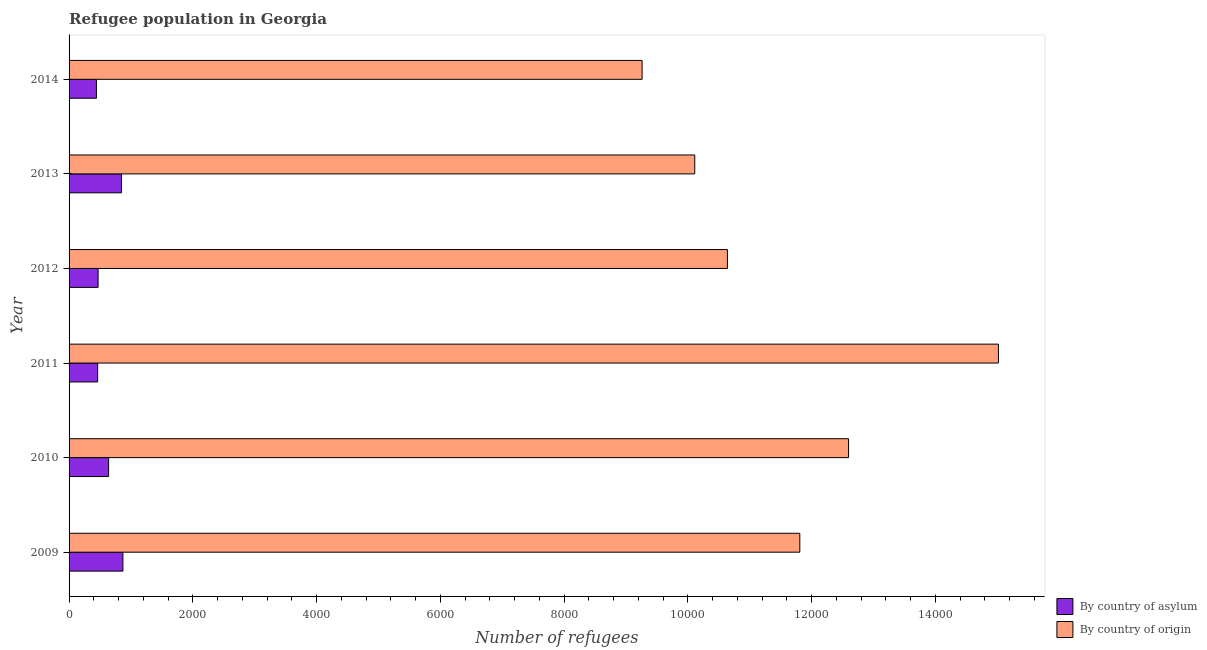How many different coloured bars are there?
Your answer should be very brief. 2. Are the number of bars per tick equal to the number of legend labels?
Keep it short and to the point. Yes. How many bars are there on the 4th tick from the bottom?
Your answer should be compact. 2. What is the label of the 4th group of bars from the top?
Your answer should be very brief. 2011. In how many cases, is the number of bars for a given year not equal to the number of legend labels?
Provide a short and direct response. 0. What is the number of refugees by country of asylum in 2014?
Make the answer very short. 442. Across all years, what is the maximum number of refugees by country of asylum?
Offer a terse response. 870. Across all years, what is the minimum number of refugees by country of origin?
Your response must be concise. 9261. What is the total number of refugees by country of asylum in the graph?
Make the answer very short. 3729. What is the difference between the number of refugees by country of asylum in 2009 and that in 2013?
Give a very brief answer. 23. What is the difference between the number of refugees by country of asylum in 2011 and the number of refugees by country of origin in 2010?
Offer a very short reply. -1.21e+04. What is the average number of refugees by country of origin per year?
Keep it short and to the point. 1.16e+04. In the year 2009, what is the difference between the number of refugees by country of origin and number of refugees by country of asylum?
Your answer should be compact. 1.09e+04. What is the ratio of the number of refugees by country of asylum in 2010 to that in 2013?
Keep it short and to the point. 0.75. Is the number of refugees by country of asylum in 2009 less than that in 2010?
Offer a terse response. No. Is the difference between the number of refugees by country of asylum in 2012 and 2013 greater than the difference between the number of refugees by country of origin in 2012 and 2013?
Ensure brevity in your answer.  No. What is the difference between the highest and the lowest number of refugees by country of origin?
Your response must be concise. 5759. Is the sum of the number of refugees by country of asylum in 2012 and 2013 greater than the maximum number of refugees by country of origin across all years?
Your answer should be compact. No. What does the 2nd bar from the top in 2009 represents?
Keep it short and to the point. By country of asylum. What does the 1st bar from the bottom in 2014 represents?
Make the answer very short. By country of asylum. Are all the bars in the graph horizontal?
Your response must be concise. Yes. Are the values on the major ticks of X-axis written in scientific E-notation?
Provide a succinct answer. No. Does the graph contain any zero values?
Your response must be concise. No. Where does the legend appear in the graph?
Your response must be concise. Bottom right. What is the title of the graph?
Your answer should be compact. Refugee population in Georgia. What is the label or title of the X-axis?
Offer a very short reply. Number of refugees. What is the Number of refugees in By country of asylum in 2009?
Give a very brief answer. 870. What is the Number of refugees in By country of origin in 2009?
Give a very brief answer. 1.18e+04. What is the Number of refugees in By country of asylum in 2010?
Your answer should be very brief. 639. What is the Number of refugees in By country of origin in 2010?
Your answer should be compact. 1.26e+04. What is the Number of refugees of By country of asylum in 2011?
Your answer should be very brief. 462. What is the Number of refugees of By country of origin in 2011?
Keep it short and to the point. 1.50e+04. What is the Number of refugees of By country of asylum in 2012?
Give a very brief answer. 469. What is the Number of refugees of By country of origin in 2012?
Your response must be concise. 1.06e+04. What is the Number of refugees in By country of asylum in 2013?
Make the answer very short. 847. What is the Number of refugees of By country of origin in 2013?
Your answer should be very brief. 1.01e+04. What is the Number of refugees of By country of asylum in 2014?
Offer a terse response. 442. What is the Number of refugees in By country of origin in 2014?
Your answer should be compact. 9261. Across all years, what is the maximum Number of refugees in By country of asylum?
Your answer should be very brief. 870. Across all years, what is the maximum Number of refugees of By country of origin?
Ensure brevity in your answer.  1.50e+04. Across all years, what is the minimum Number of refugees of By country of asylum?
Keep it short and to the point. 442. Across all years, what is the minimum Number of refugees of By country of origin?
Your answer should be compact. 9261. What is the total Number of refugees of By country of asylum in the graph?
Ensure brevity in your answer.  3729. What is the total Number of refugees in By country of origin in the graph?
Keep it short and to the point. 6.94e+04. What is the difference between the Number of refugees in By country of asylum in 2009 and that in 2010?
Offer a terse response. 231. What is the difference between the Number of refugees in By country of origin in 2009 and that in 2010?
Offer a terse response. -788. What is the difference between the Number of refugees of By country of asylum in 2009 and that in 2011?
Offer a very short reply. 408. What is the difference between the Number of refugees of By country of origin in 2009 and that in 2011?
Provide a succinct answer. -3210. What is the difference between the Number of refugees of By country of asylum in 2009 and that in 2012?
Your answer should be very brief. 401. What is the difference between the Number of refugees in By country of origin in 2009 and that in 2012?
Keep it short and to the point. 1170. What is the difference between the Number of refugees in By country of asylum in 2009 and that in 2013?
Provide a short and direct response. 23. What is the difference between the Number of refugees of By country of origin in 2009 and that in 2013?
Your answer should be compact. 1698. What is the difference between the Number of refugees of By country of asylum in 2009 and that in 2014?
Ensure brevity in your answer.  428. What is the difference between the Number of refugees of By country of origin in 2009 and that in 2014?
Offer a terse response. 2549. What is the difference between the Number of refugees of By country of asylum in 2010 and that in 2011?
Provide a succinct answer. 177. What is the difference between the Number of refugees of By country of origin in 2010 and that in 2011?
Keep it short and to the point. -2422. What is the difference between the Number of refugees in By country of asylum in 2010 and that in 2012?
Your answer should be very brief. 170. What is the difference between the Number of refugees in By country of origin in 2010 and that in 2012?
Your answer should be very brief. 1958. What is the difference between the Number of refugees of By country of asylum in 2010 and that in 2013?
Your response must be concise. -208. What is the difference between the Number of refugees in By country of origin in 2010 and that in 2013?
Give a very brief answer. 2486. What is the difference between the Number of refugees of By country of asylum in 2010 and that in 2014?
Your answer should be very brief. 197. What is the difference between the Number of refugees of By country of origin in 2010 and that in 2014?
Make the answer very short. 3337. What is the difference between the Number of refugees of By country of origin in 2011 and that in 2012?
Your response must be concise. 4380. What is the difference between the Number of refugees of By country of asylum in 2011 and that in 2013?
Ensure brevity in your answer.  -385. What is the difference between the Number of refugees in By country of origin in 2011 and that in 2013?
Provide a succinct answer. 4908. What is the difference between the Number of refugees in By country of origin in 2011 and that in 2014?
Offer a very short reply. 5759. What is the difference between the Number of refugees of By country of asylum in 2012 and that in 2013?
Provide a succinct answer. -378. What is the difference between the Number of refugees of By country of origin in 2012 and that in 2013?
Offer a terse response. 528. What is the difference between the Number of refugees of By country of origin in 2012 and that in 2014?
Make the answer very short. 1379. What is the difference between the Number of refugees in By country of asylum in 2013 and that in 2014?
Provide a short and direct response. 405. What is the difference between the Number of refugees in By country of origin in 2013 and that in 2014?
Offer a terse response. 851. What is the difference between the Number of refugees in By country of asylum in 2009 and the Number of refugees in By country of origin in 2010?
Make the answer very short. -1.17e+04. What is the difference between the Number of refugees in By country of asylum in 2009 and the Number of refugees in By country of origin in 2011?
Ensure brevity in your answer.  -1.42e+04. What is the difference between the Number of refugees of By country of asylum in 2009 and the Number of refugees of By country of origin in 2012?
Your answer should be very brief. -9770. What is the difference between the Number of refugees in By country of asylum in 2009 and the Number of refugees in By country of origin in 2013?
Provide a short and direct response. -9242. What is the difference between the Number of refugees of By country of asylum in 2009 and the Number of refugees of By country of origin in 2014?
Offer a terse response. -8391. What is the difference between the Number of refugees in By country of asylum in 2010 and the Number of refugees in By country of origin in 2011?
Ensure brevity in your answer.  -1.44e+04. What is the difference between the Number of refugees of By country of asylum in 2010 and the Number of refugees of By country of origin in 2012?
Your answer should be very brief. -1.00e+04. What is the difference between the Number of refugees of By country of asylum in 2010 and the Number of refugees of By country of origin in 2013?
Offer a very short reply. -9473. What is the difference between the Number of refugees in By country of asylum in 2010 and the Number of refugees in By country of origin in 2014?
Your answer should be very brief. -8622. What is the difference between the Number of refugees in By country of asylum in 2011 and the Number of refugees in By country of origin in 2012?
Ensure brevity in your answer.  -1.02e+04. What is the difference between the Number of refugees of By country of asylum in 2011 and the Number of refugees of By country of origin in 2013?
Offer a terse response. -9650. What is the difference between the Number of refugees in By country of asylum in 2011 and the Number of refugees in By country of origin in 2014?
Give a very brief answer. -8799. What is the difference between the Number of refugees in By country of asylum in 2012 and the Number of refugees in By country of origin in 2013?
Offer a very short reply. -9643. What is the difference between the Number of refugees in By country of asylum in 2012 and the Number of refugees in By country of origin in 2014?
Keep it short and to the point. -8792. What is the difference between the Number of refugees in By country of asylum in 2013 and the Number of refugees in By country of origin in 2014?
Provide a short and direct response. -8414. What is the average Number of refugees of By country of asylum per year?
Offer a terse response. 621.5. What is the average Number of refugees of By country of origin per year?
Provide a succinct answer. 1.16e+04. In the year 2009, what is the difference between the Number of refugees of By country of asylum and Number of refugees of By country of origin?
Offer a terse response. -1.09e+04. In the year 2010, what is the difference between the Number of refugees of By country of asylum and Number of refugees of By country of origin?
Your answer should be very brief. -1.20e+04. In the year 2011, what is the difference between the Number of refugees of By country of asylum and Number of refugees of By country of origin?
Give a very brief answer. -1.46e+04. In the year 2012, what is the difference between the Number of refugees of By country of asylum and Number of refugees of By country of origin?
Ensure brevity in your answer.  -1.02e+04. In the year 2013, what is the difference between the Number of refugees in By country of asylum and Number of refugees in By country of origin?
Give a very brief answer. -9265. In the year 2014, what is the difference between the Number of refugees in By country of asylum and Number of refugees in By country of origin?
Your response must be concise. -8819. What is the ratio of the Number of refugees in By country of asylum in 2009 to that in 2010?
Offer a terse response. 1.36. What is the ratio of the Number of refugees in By country of asylum in 2009 to that in 2011?
Ensure brevity in your answer.  1.88. What is the ratio of the Number of refugees of By country of origin in 2009 to that in 2011?
Ensure brevity in your answer.  0.79. What is the ratio of the Number of refugees of By country of asylum in 2009 to that in 2012?
Your answer should be compact. 1.85. What is the ratio of the Number of refugees of By country of origin in 2009 to that in 2012?
Your response must be concise. 1.11. What is the ratio of the Number of refugees in By country of asylum in 2009 to that in 2013?
Offer a terse response. 1.03. What is the ratio of the Number of refugees in By country of origin in 2009 to that in 2013?
Make the answer very short. 1.17. What is the ratio of the Number of refugees in By country of asylum in 2009 to that in 2014?
Your response must be concise. 1.97. What is the ratio of the Number of refugees in By country of origin in 2009 to that in 2014?
Provide a short and direct response. 1.28. What is the ratio of the Number of refugees of By country of asylum in 2010 to that in 2011?
Your answer should be very brief. 1.38. What is the ratio of the Number of refugees of By country of origin in 2010 to that in 2011?
Make the answer very short. 0.84. What is the ratio of the Number of refugees in By country of asylum in 2010 to that in 2012?
Make the answer very short. 1.36. What is the ratio of the Number of refugees in By country of origin in 2010 to that in 2012?
Give a very brief answer. 1.18. What is the ratio of the Number of refugees in By country of asylum in 2010 to that in 2013?
Make the answer very short. 0.75. What is the ratio of the Number of refugees in By country of origin in 2010 to that in 2013?
Your response must be concise. 1.25. What is the ratio of the Number of refugees of By country of asylum in 2010 to that in 2014?
Make the answer very short. 1.45. What is the ratio of the Number of refugees of By country of origin in 2010 to that in 2014?
Make the answer very short. 1.36. What is the ratio of the Number of refugees of By country of asylum in 2011 to that in 2012?
Your response must be concise. 0.99. What is the ratio of the Number of refugees of By country of origin in 2011 to that in 2012?
Provide a succinct answer. 1.41. What is the ratio of the Number of refugees of By country of asylum in 2011 to that in 2013?
Ensure brevity in your answer.  0.55. What is the ratio of the Number of refugees in By country of origin in 2011 to that in 2013?
Provide a short and direct response. 1.49. What is the ratio of the Number of refugees in By country of asylum in 2011 to that in 2014?
Provide a short and direct response. 1.05. What is the ratio of the Number of refugees of By country of origin in 2011 to that in 2014?
Make the answer very short. 1.62. What is the ratio of the Number of refugees of By country of asylum in 2012 to that in 2013?
Keep it short and to the point. 0.55. What is the ratio of the Number of refugees of By country of origin in 2012 to that in 2013?
Provide a short and direct response. 1.05. What is the ratio of the Number of refugees in By country of asylum in 2012 to that in 2014?
Keep it short and to the point. 1.06. What is the ratio of the Number of refugees of By country of origin in 2012 to that in 2014?
Ensure brevity in your answer.  1.15. What is the ratio of the Number of refugees of By country of asylum in 2013 to that in 2014?
Give a very brief answer. 1.92. What is the ratio of the Number of refugees in By country of origin in 2013 to that in 2014?
Make the answer very short. 1.09. What is the difference between the highest and the second highest Number of refugees of By country of origin?
Provide a succinct answer. 2422. What is the difference between the highest and the lowest Number of refugees in By country of asylum?
Provide a succinct answer. 428. What is the difference between the highest and the lowest Number of refugees in By country of origin?
Your response must be concise. 5759. 